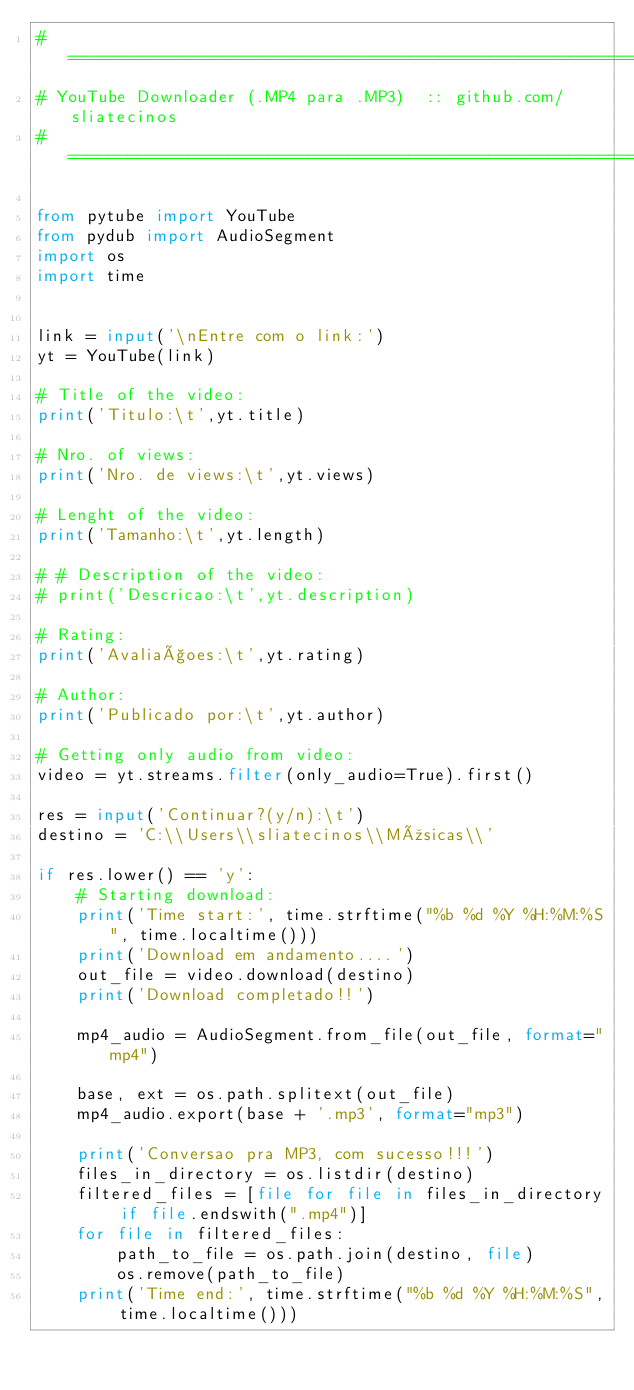Convert code to text. <code><loc_0><loc_0><loc_500><loc_500><_Python_># ================================================================
# YouTube Downloader (.MP4 para .MP3)  :: github.com/sliatecinos
# ================================================================

from pytube import YouTube
from pydub import AudioSegment
import os
import time


link = input('\nEntre com o link:')
yt = YouTube(link)

# Title of the video:
print('Titulo:\t',yt.title)

# Nro. of views:
print('Nro. de views:\t',yt.views)

# Lenght of the video:
print('Tamanho:\t',yt.length)

# # Description of the video:
# print('Descricao:\t',yt.description)

# Rating:
print('Avaliaçoes:\t',yt.rating)

# Author:
print('Publicado por:\t',yt.author)

# Getting only audio from video:
video = yt.streams.filter(only_audio=True).first()

res = input('Continuar?(y/n):\t')
destino = 'C:\\Users\\sliatecinos\\Músicas\\'

if res.lower() == 'y':
    # Starting download:
    print('Time start:', time.strftime("%b %d %Y %H:%M:%S", time.localtime()))
    print('Download em andamento....')
    out_file = video.download(destino)
    print('Download completado!!')

    mp4_audio = AudioSegment.from_file(out_file, format="mp4")

    base, ext = os.path.splitext(out_file)
    mp4_audio.export(base + '.mp3', format="mp3")

    print('Conversao pra MP3, com sucesso!!!')
    files_in_directory = os.listdir(destino)
    filtered_files = [file for file in files_in_directory if file.endswith(".mp4")]
    for file in filtered_files:
        path_to_file = os.path.join(destino, file)
        os.remove(path_to_file)
    print('Time end:', time.strftime("%b %d %Y %H:%M:%S", time.localtime()))

</code> 